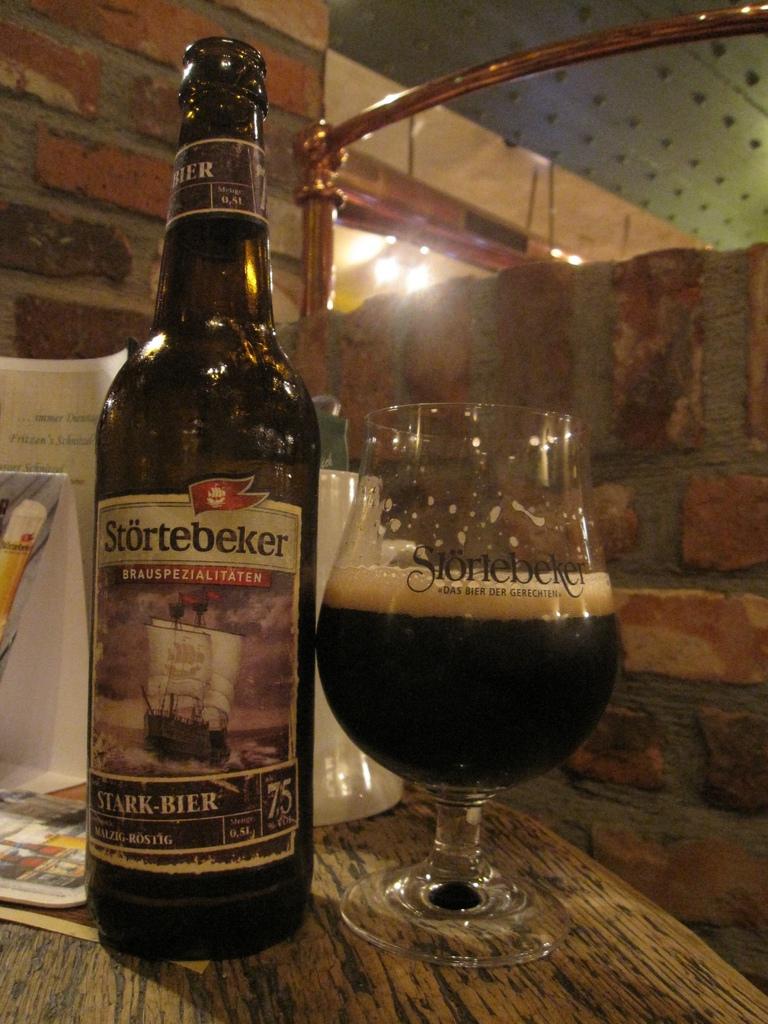What kind of drink is this?
Offer a terse response. Beer. 